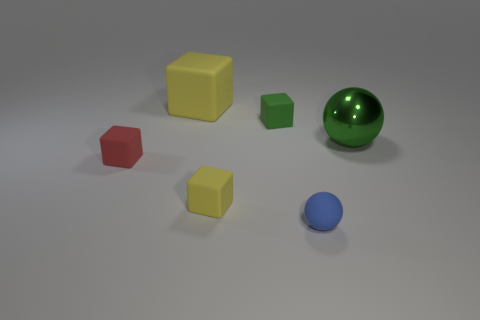Add 1 large green objects. How many objects exist? 7 Subtract all balls. How many objects are left? 4 Subtract 0 yellow cylinders. How many objects are left? 6 Subtract all large purple spheres. Subtract all yellow rubber things. How many objects are left? 4 Add 2 tiny rubber things. How many tiny rubber things are left? 6 Add 3 cyan shiny cylinders. How many cyan shiny cylinders exist? 3 